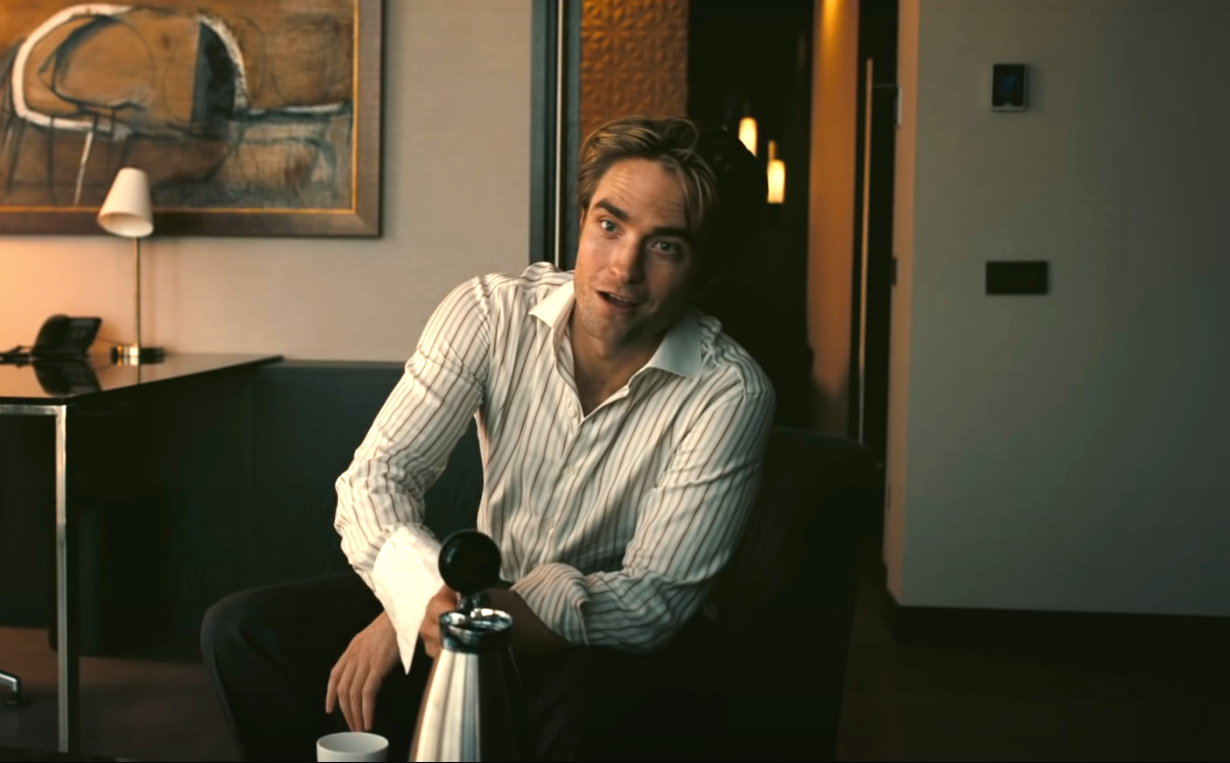Describe a realistic scenario where the man in the image could be engaging in a profound conversation. In a realistic scenario, the man in the image could be having an intimate conversation with a close friend or loved one about life's deeper meanings and personal philosophies. The peaceful and sophisticated setting of the living room makes it an ideal environment for such a discussion. As they sit across from each other, with the silver water pitcher and cups of tea on the coffee table, they exchange thoughts on their life experiences, dreams, and aspirations. The relaxed and cozy atmosphere encourages openness and honest sharing, deepening their bond and understanding of each other.  What might be a short, realistic scenario for the image? In a short, realistic scenario, the man might have just returned home after a long day at work. He sits on the couch to unwind, holding the water pitcher to pour himself a refreshing drink. Taking a moment to relax, he looks to the side, catching a glimpse of his favorite painting. The serene atmosphere of the room helps him decompress as he enjoys a peaceful evening in his well-decorated living space. 